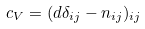<formula> <loc_0><loc_0><loc_500><loc_500>c _ { V } = ( d \delta _ { i j } - n _ { i j } ) _ { i j }</formula> 